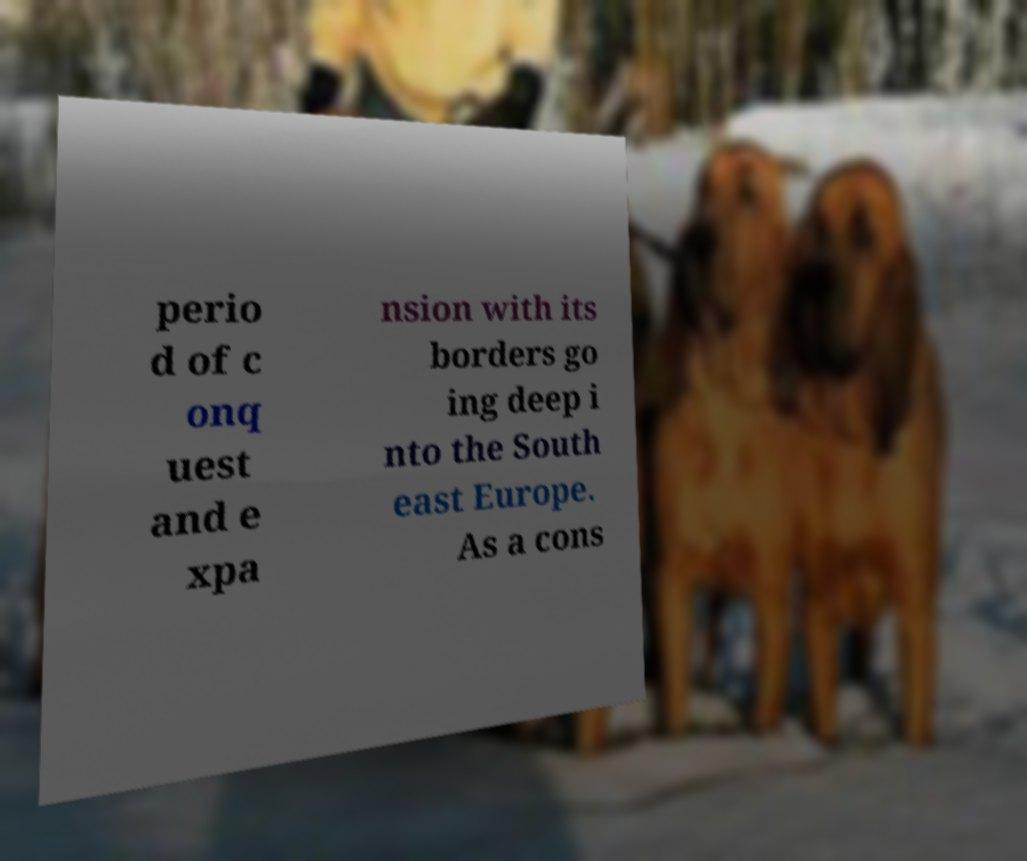Please identify and transcribe the text found in this image. perio d of c onq uest and e xpa nsion with its borders go ing deep i nto the South east Europe. As a cons 